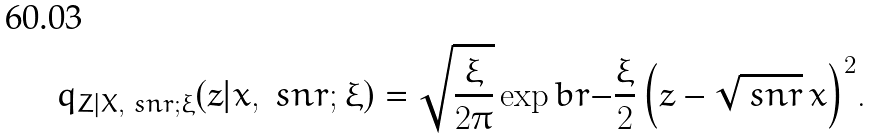<formula> <loc_0><loc_0><loc_500><loc_500>q _ { Z | X , \ s n r ; \xi } ( z | x , \ s n r ; \xi ) = \sqrt { \frac { \xi } { 2 \pi } } \exp b r { - \frac { \xi } { 2 } \left ( z - \sqrt { \ s n r } \, x \right ) ^ { 2 } } .</formula> 